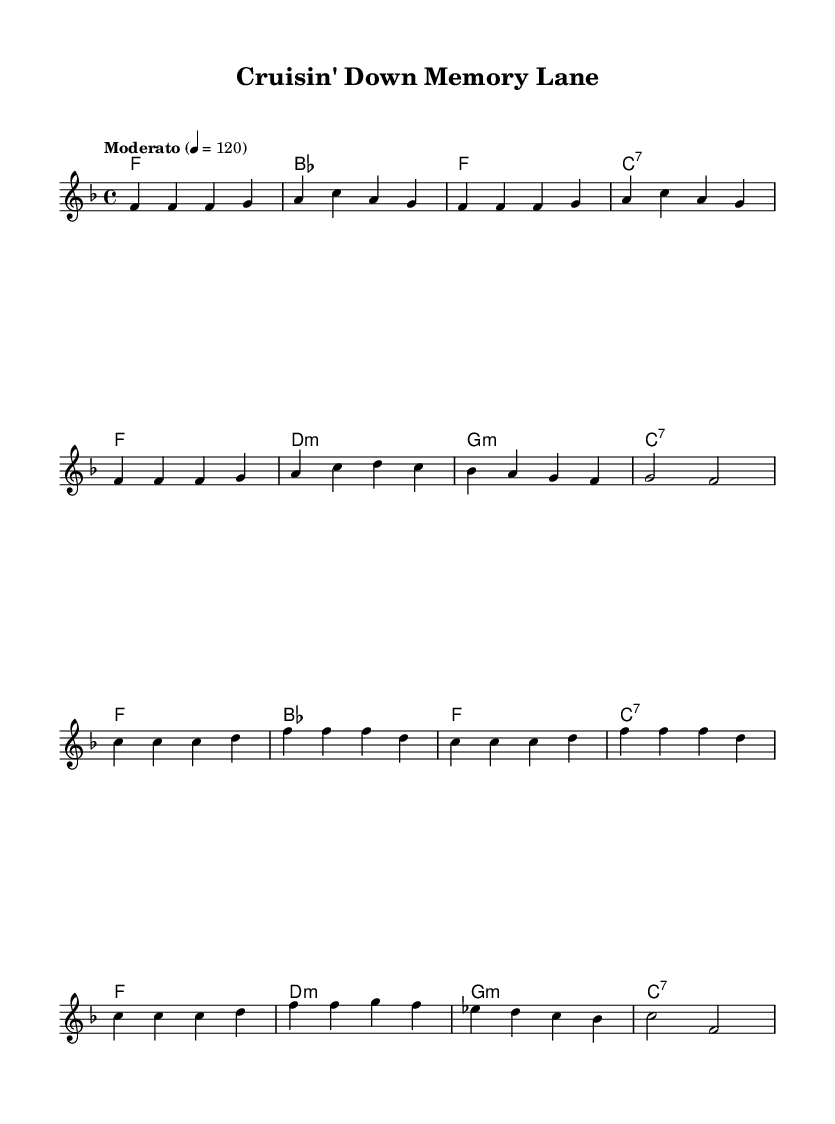What is the key signature of this music? The key signature is F major, which has one flat (B♭). It is determined by looking at the key indicated at the beginning of the sheet music, which tells us which notes will be sharp or flat.
Answer: F major What is the time signature of this piece? The time signature is 4/4, indicated at the beginning of the sheet music. This means there are four beats per measure, and the quarter note gets one beat.
Answer: 4/4 What is the tempo marking for this music? The tempo marking is "Moderato," which suggests a moderate speed, typically around 108 to 120 beats per minute. The exact BPM is specified as 120 in the score.
Answer: Moderato How many measures are in the verse section? The verse section consists of 8 measures, which can be counted by analyzing the distinct groupings of bars following the initial introductory measures on the sheet.
Answer: 8 measures What is the primary scale degree of the first measure? The primary scale degree of the first measure is F, as it begins with the note F in the melody line, which is the tonic of the F major scale.
Answer: F What is the chord used in the chorus at the start of each measure? The chord used at the start of each measure in the chorus is F major, which is indicated by the chord symbols above the melody line corresponding to the measures in the chorus.
Answer: F What defines this music as Rhythm and Blues? This music features a soulful melody, a strong backbeat, and a focus on vocal expressions common in rhythm and blues, which can be deduced from the musical structure and style presented in the sheet.
Answer: Soulful melody 